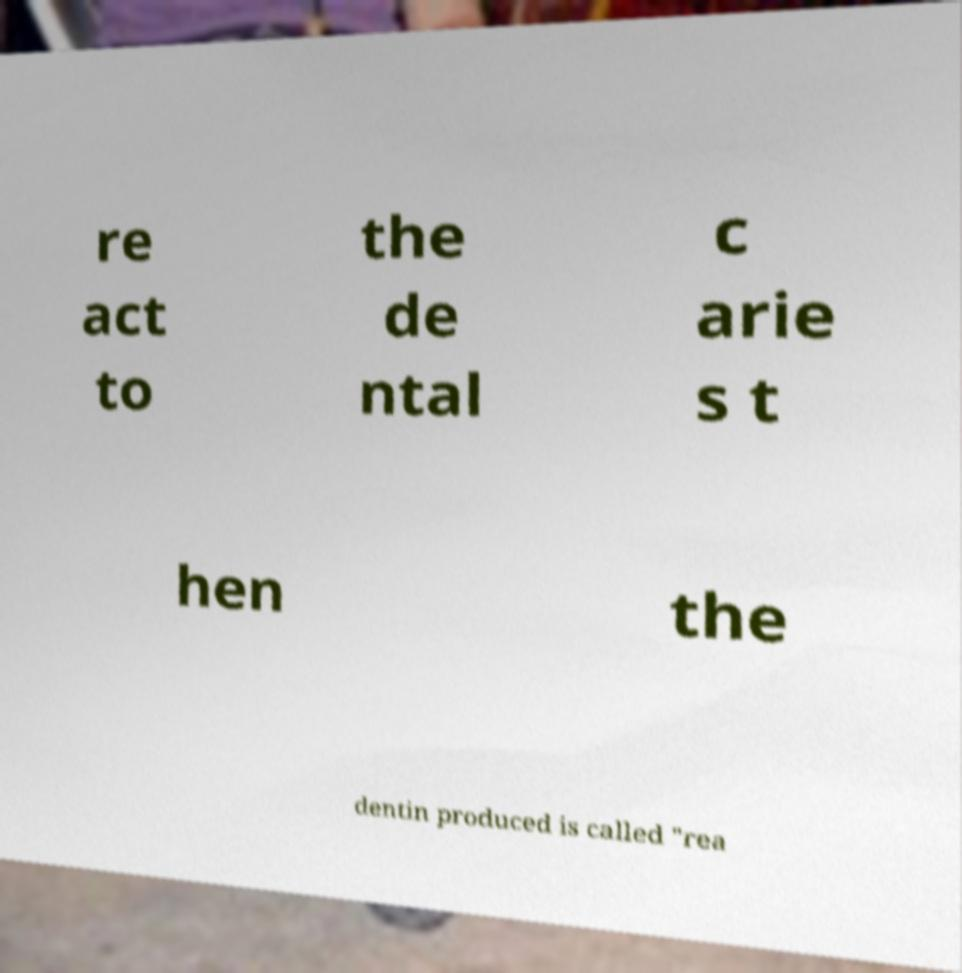Could you extract and type out the text from this image? re act to the de ntal c arie s t hen the dentin produced is called "rea 